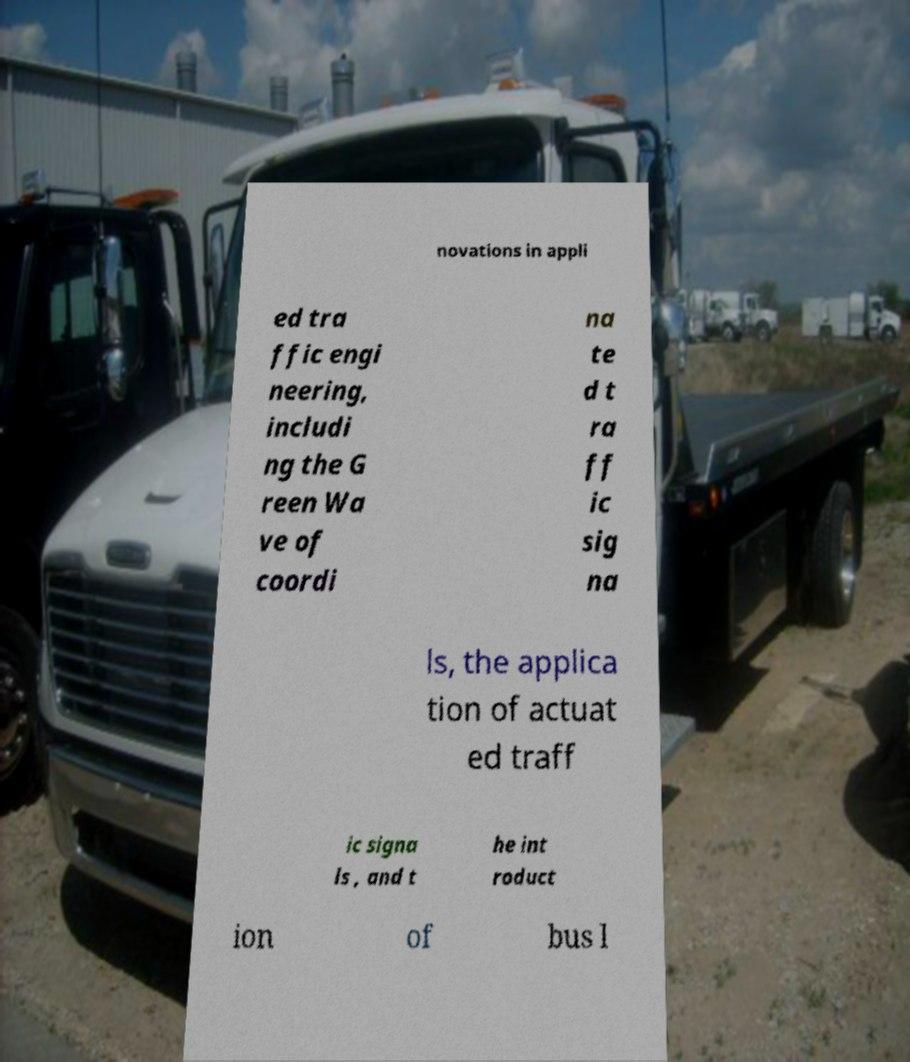For documentation purposes, I need the text within this image transcribed. Could you provide that? novations in appli ed tra ffic engi neering, includi ng the G reen Wa ve of coordi na te d t ra ff ic sig na ls, the applica tion of actuat ed traff ic signa ls , and t he int roduct ion of bus l 